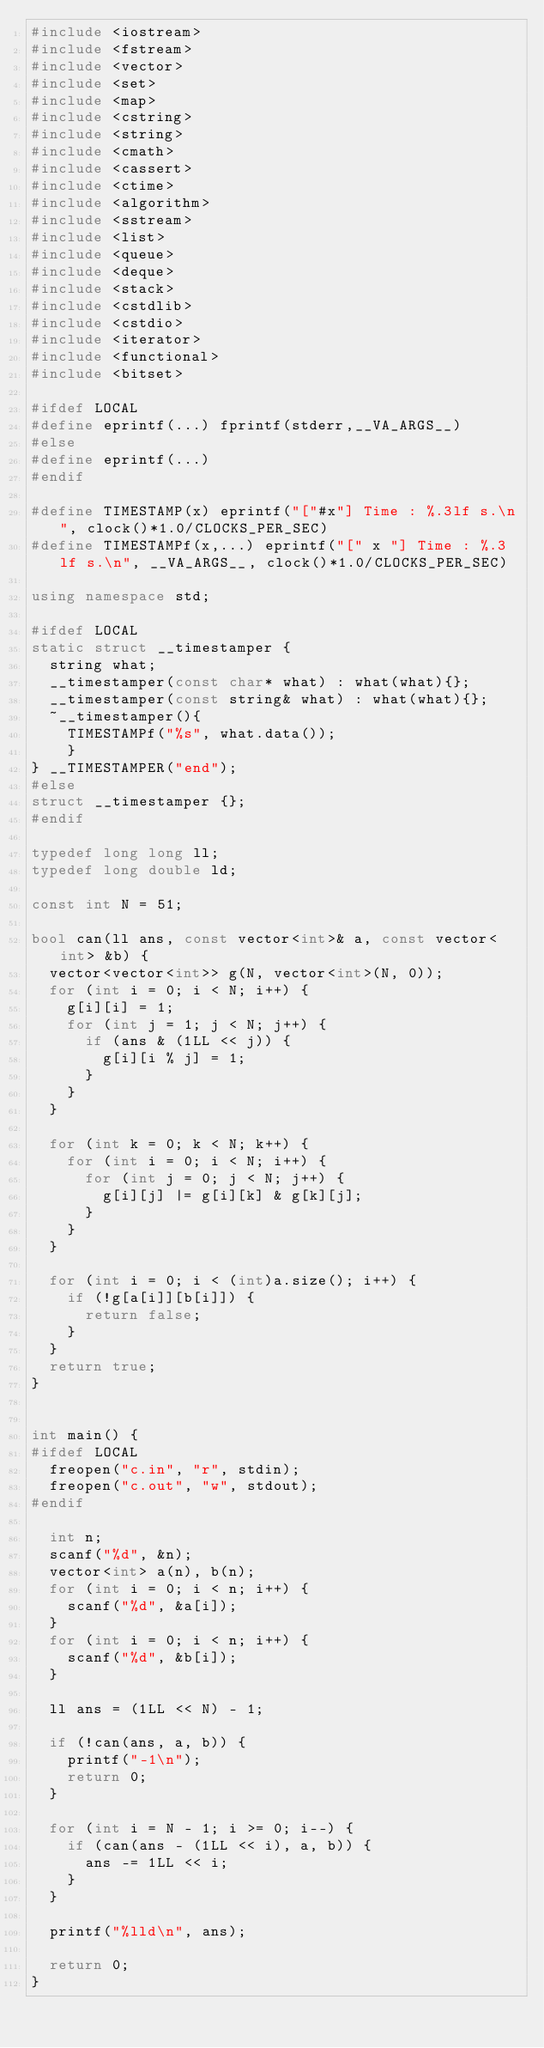<code> <loc_0><loc_0><loc_500><loc_500><_C++_>#include <iostream>
#include <fstream>
#include <vector>
#include <set>
#include <map>
#include <cstring>
#include <string>
#include <cmath>
#include <cassert>
#include <ctime>
#include <algorithm>
#include <sstream>
#include <list>
#include <queue>
#include <deque>
#include <stack>
#include <cstdlib>
#include <cstdio>
#include <iterator>
#include <functional>
#include <bitset>

#ifdef LOCAL
#define eprintf(...) fprintf(stderr,__VA_ARGS__)
#else
#define eprintf(...)
#endif

#define TIMESTAMP(x) eprintf("["#x"] Time : %.3lf s.\n", clock()*1.0/CLOCKS_PER_SEC)
#define TIMESTAMPf(x,...) eprintf("[" x "] Time : %.3lf s.\n", __VA_ARGS__, clock()*1.0/CLOCKS_PER_SEC)

using namespace std;

#ifdef LOCAL
static struct __timestamper {
  string what;
  __timestamper(const char* what) : what(what){};
  __timestamper(const string& what) : what(what){};
  ~__timestamper(){
    TIMESTAMPf("%s", what.data());
	}
} __TIMESTAMPER("end");
#else 
struct __timestamper {};
#endif

typedef long long ll;
typedef long double ld;

const int N = 51;

bool can(ll ans, const vector<int>& a, const vector<int> &b) {
  vector<vector<int>> g(N, vector<int>(N, 0));
  for (int i = 0; i < N; i++) {
    g[i][i] = 1;
    for (int j = 1; j < N; j++) {
      if (ans & (1LL << j)) {
        g[i][i % j] = 1;
      }
    }
  }

  for (int k = 0; k < N; k++) {
    for (int i = 0; i < N; i++) {
      for (int j = 0; j < N; j++) {
        g[i][j] |= g[i][k] & g[k][j];
      }
    }
  }

  for (int i = 0; i < (int)a.size(); i++) {
    if (!g[a[i]][b[i]]) {
      return false;
    }
  }
  return true;
}


int main() {
#ifdef LOCAL
  freopen("c.in", "r", stdin);
  freopen("c.out", "w", stdout);
#endif

  int n;
  scanf("%d", &n);
  vector<int> a(n), b(n);
  for (int i = 0; i < n; i++) {
    scanf("%d", &a[i]);
  }
  for (int i = 0; i < n; i++) {
    scanf("%d", &b[i]);
  }

  ll ans = (1LL << N) - 1;

  if (!can(ans, a, b)) {
    printf("-1\n");
    return 0;
  }

  for (int i = N - 1; i >= 0; i--) {
    if (can(ans - (1LL << i), a, b)) {
      ans -= 1LL << i;
    }
  }

  printf("%lld\n", ans);

  return 0;
}
</code> 